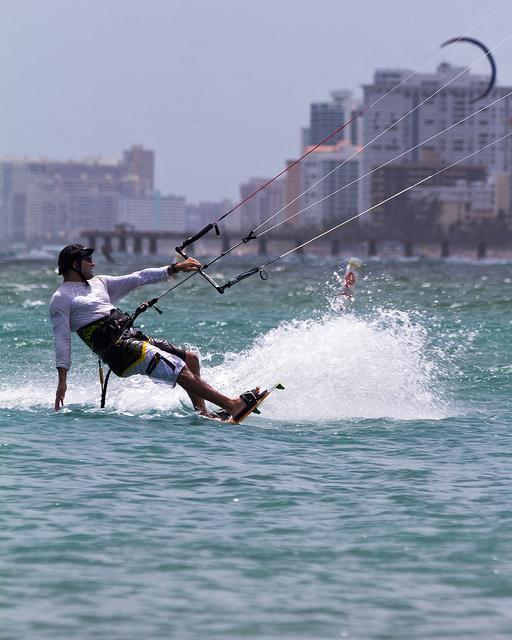How many strings is attached to the handle?
Give a very brief answer. 4. How many umbrellas are in the photo?
Give a very brief answer. 0. 